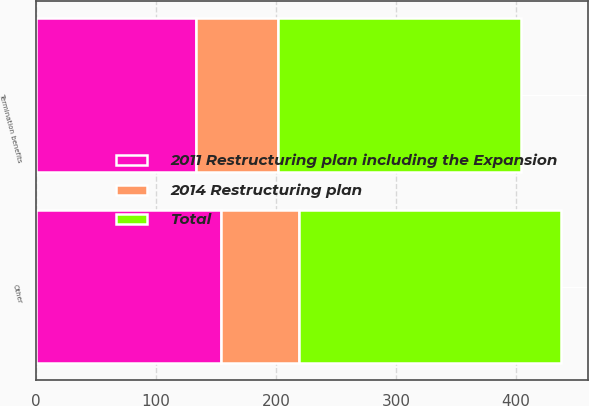Convert chart. <chart><loc_0><loc_0><loc_500><loc_500><stacked_bar_chart><ecel><fcel>Termination benefits<fcel>Other<nl><fcel>2014 Restructuring plan<fcel>69<fcel>65<nl><fcel>2011 Restructuring plan including the Expansion<fcel>133<fcel>154<nl><fcel>Total<fcel>202<fcel>219<nl></chart> 